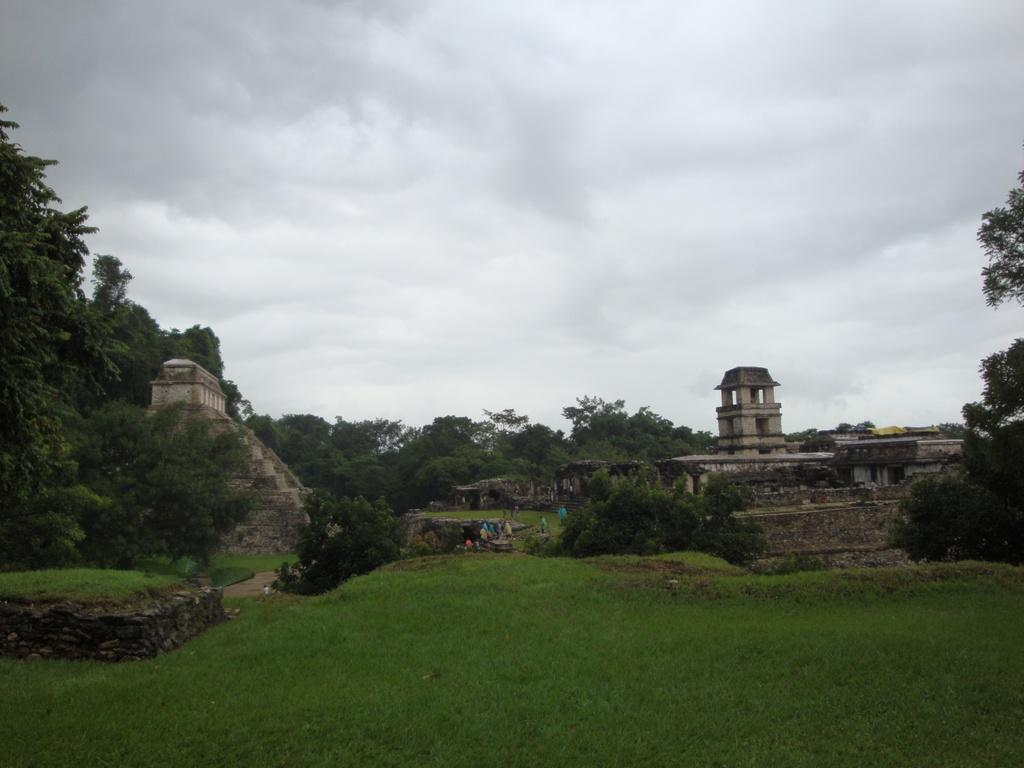How many people are in the image? There are people in the image, but the exact number is not specified. Where are the people located in the image? The people are on a grassland in the image. What type of vegetation can be seen in the image? There are plants and trees visible in the image. What type of structures are present in the image? There are walls and buildings in the image. What is visible at the top of the image? The sky is visible at the top of the image. Can you tell me how many kites are being flown by the people in the image? There is no mention of kites in the image, so it is not possible to answer this question. 